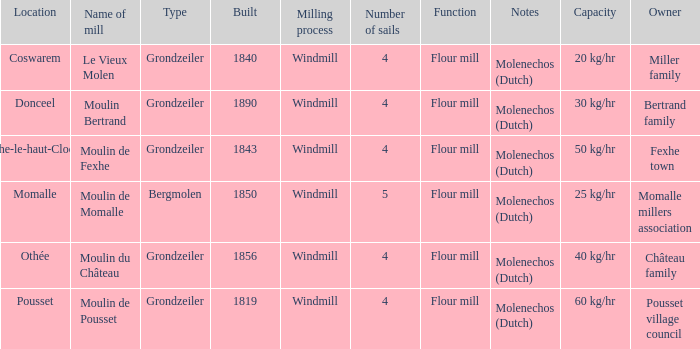What is year Built of the Moulin de Momalle Mill? 1850.0. 